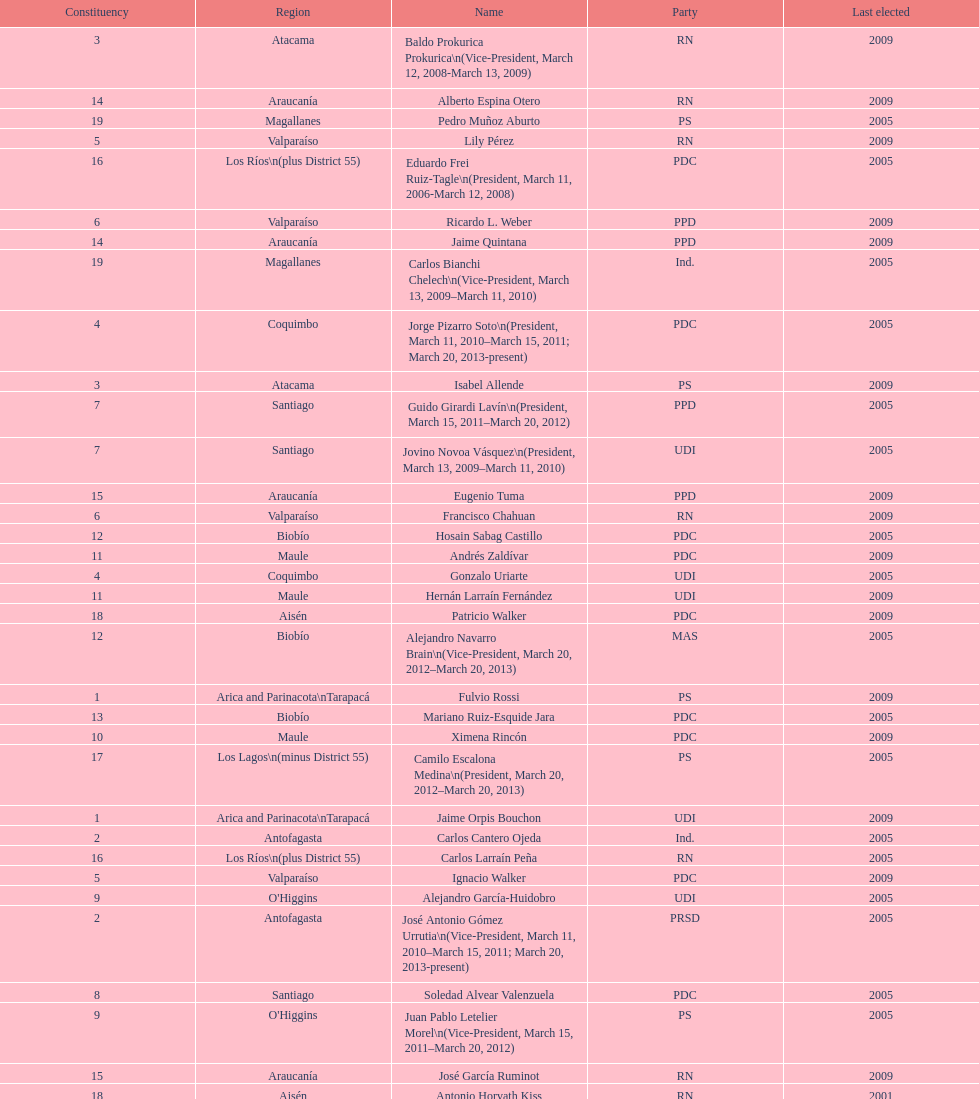What is the difference in years between constiuency 1 and 2? 4 years. 